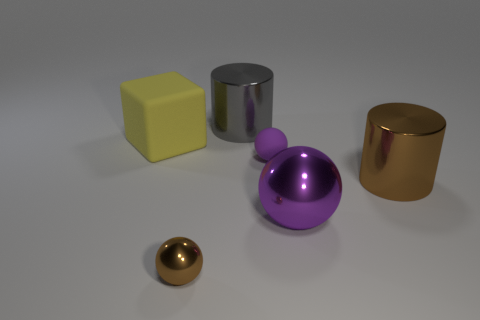Add 3 tiny yellow rubber balls. How many objects exist? 9 Subtract all cylinders. How many objects are left? 4 Add 2 tiny purple matte objects. How many tiny purple matte objects exist? 3 Subtract 0 purple blocks. How many objects are left? 6 Subtract all metallic objects. Subtract all small purple balls. How many objects are left? 1 Add 3 yellow things. How many yellow things are left? 4 